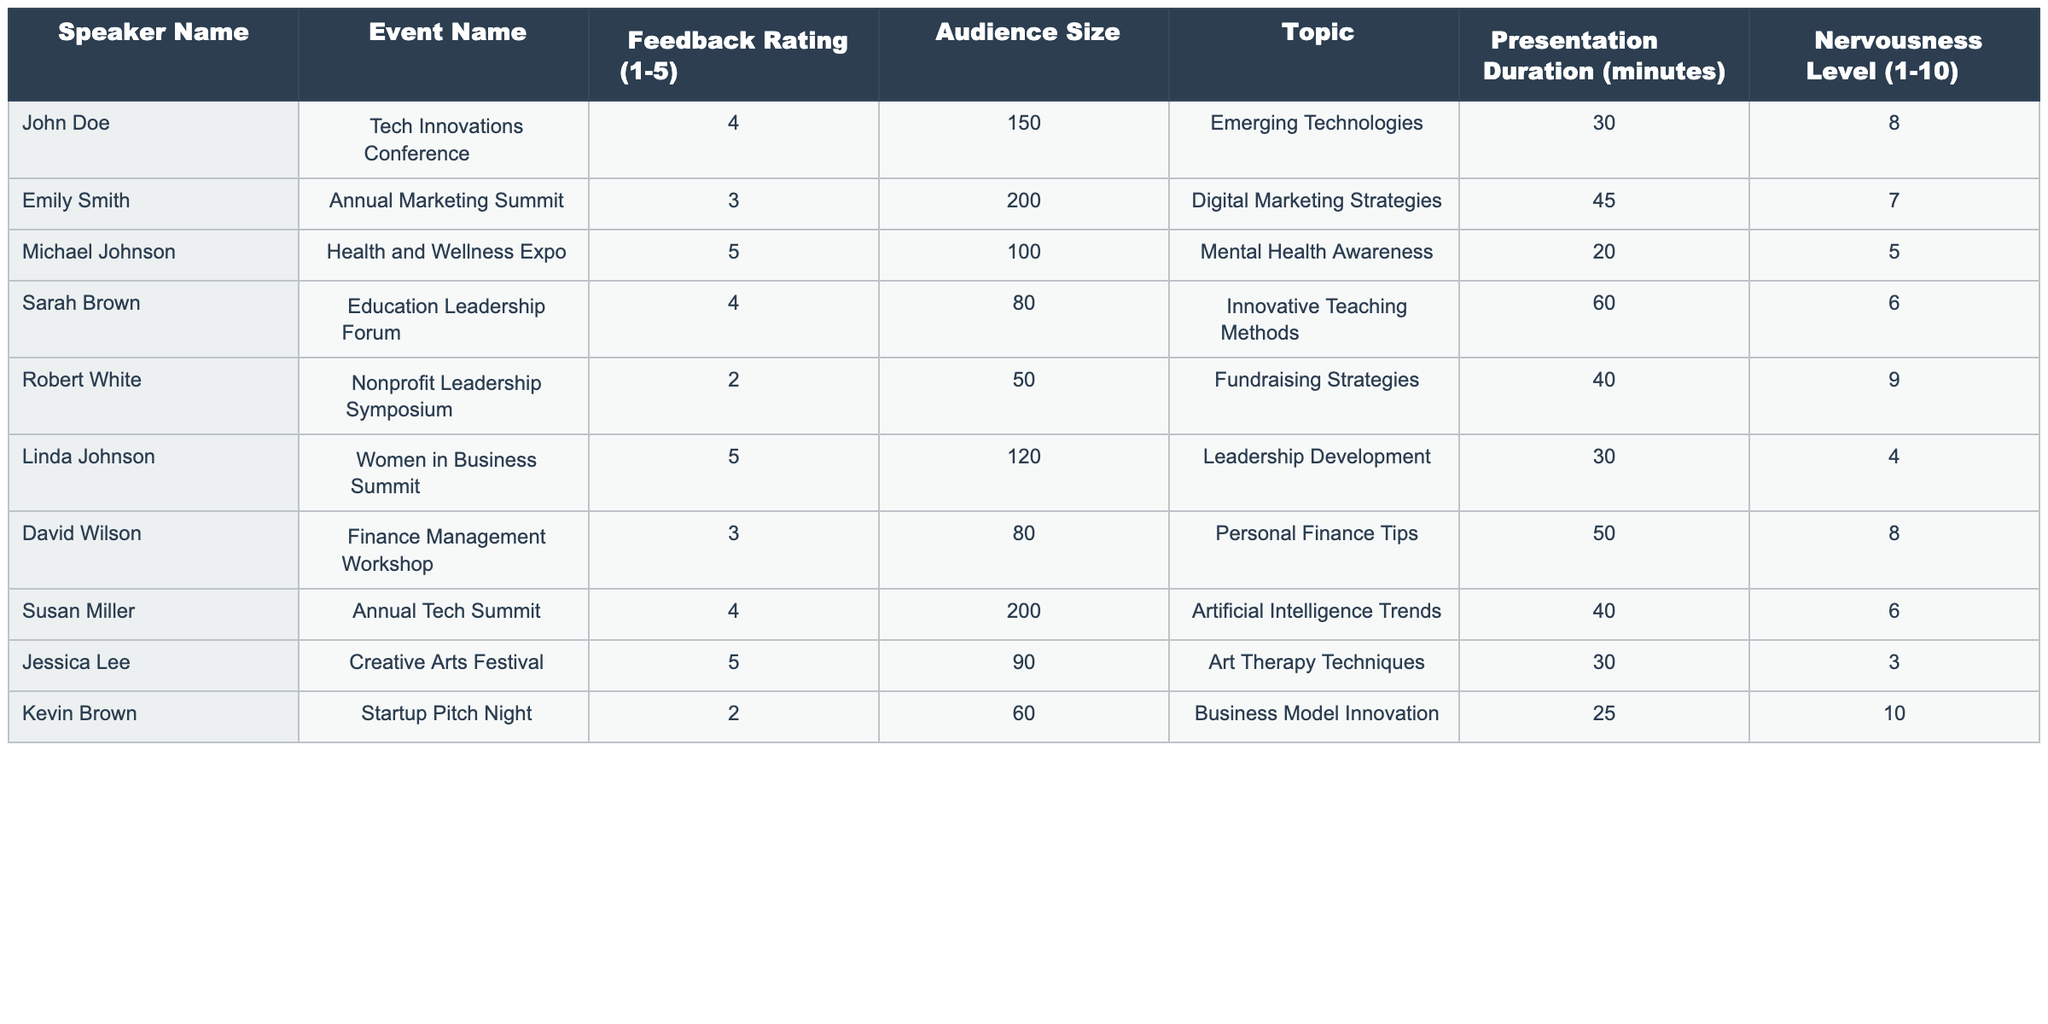What's the feedback rating for Michael Johnson? The table shows the feedback rating for Michael Johnson under the "Feedback Rating (1-5)" column, which is 5.
Answer: 5 Which speaker delivered a presentation on Digital Marketing Strategies? By looking at the "Topic" column, I can see that Emily Smith is the speaker who delivered the presentation on Digital Marketing Strategies.
Answer: Emily Smith What was the audience size at the Tech Innovations Conference? Referring to the "Audience Size" column for the Tech Innovations Conference, the size is 150.
Answer: 150 Who had the highest nervousness level among all the speakers? Checking the "Nervousness Level (1-10)" column, Kevin Brown has the highest nervousness level of 10.
Answer: Kevin Brown What is the average feedback rating of all the speakers? To find the average, I sum all the feedback ratings: (4 + 3 + 5 + 4 + 2 + 5 + 3 + 4 + 5 + 2) = 43. There are 10 speakers, so the average rating is 43/10 = 4.3.
Answer: 4.3 What percentage of speakers received a feedback rating of 4 or higher? There are 6 speakers with ratings of 4 or 5 out of 10 speakers total. Therefore, the percentage is (6/10) * 100 = 60%.
Answer: 60% Was there any speaker who gave a presentation on Fundraising Strategies? Yes, Robert White gave a presentation on Fundraising Strategies based on the "Topic" column.
Answer: Yes Which topic had the lowest feedback rating, and what was that rating? The lowest feedback rating is 2, associated with the topic Fundraising Strategies presented by Robert White.
Answer: Fundraising Strategies, 2 How does the feedback rating correlate with the nervousness level? I observe that Robert White, who had the highest nervousness level (9) also received the lowest feedback rating (2), showing a potential negative correlation.
Answer: Negative correlation What was the total presentation duration for all speakers combined? Summing up all presentation durations: (30 + 45 + 20 + 60 + 40 + 30 + 50 + 40 + 30 + 25) = 430 minutes total.
Answer: 430 minutes 